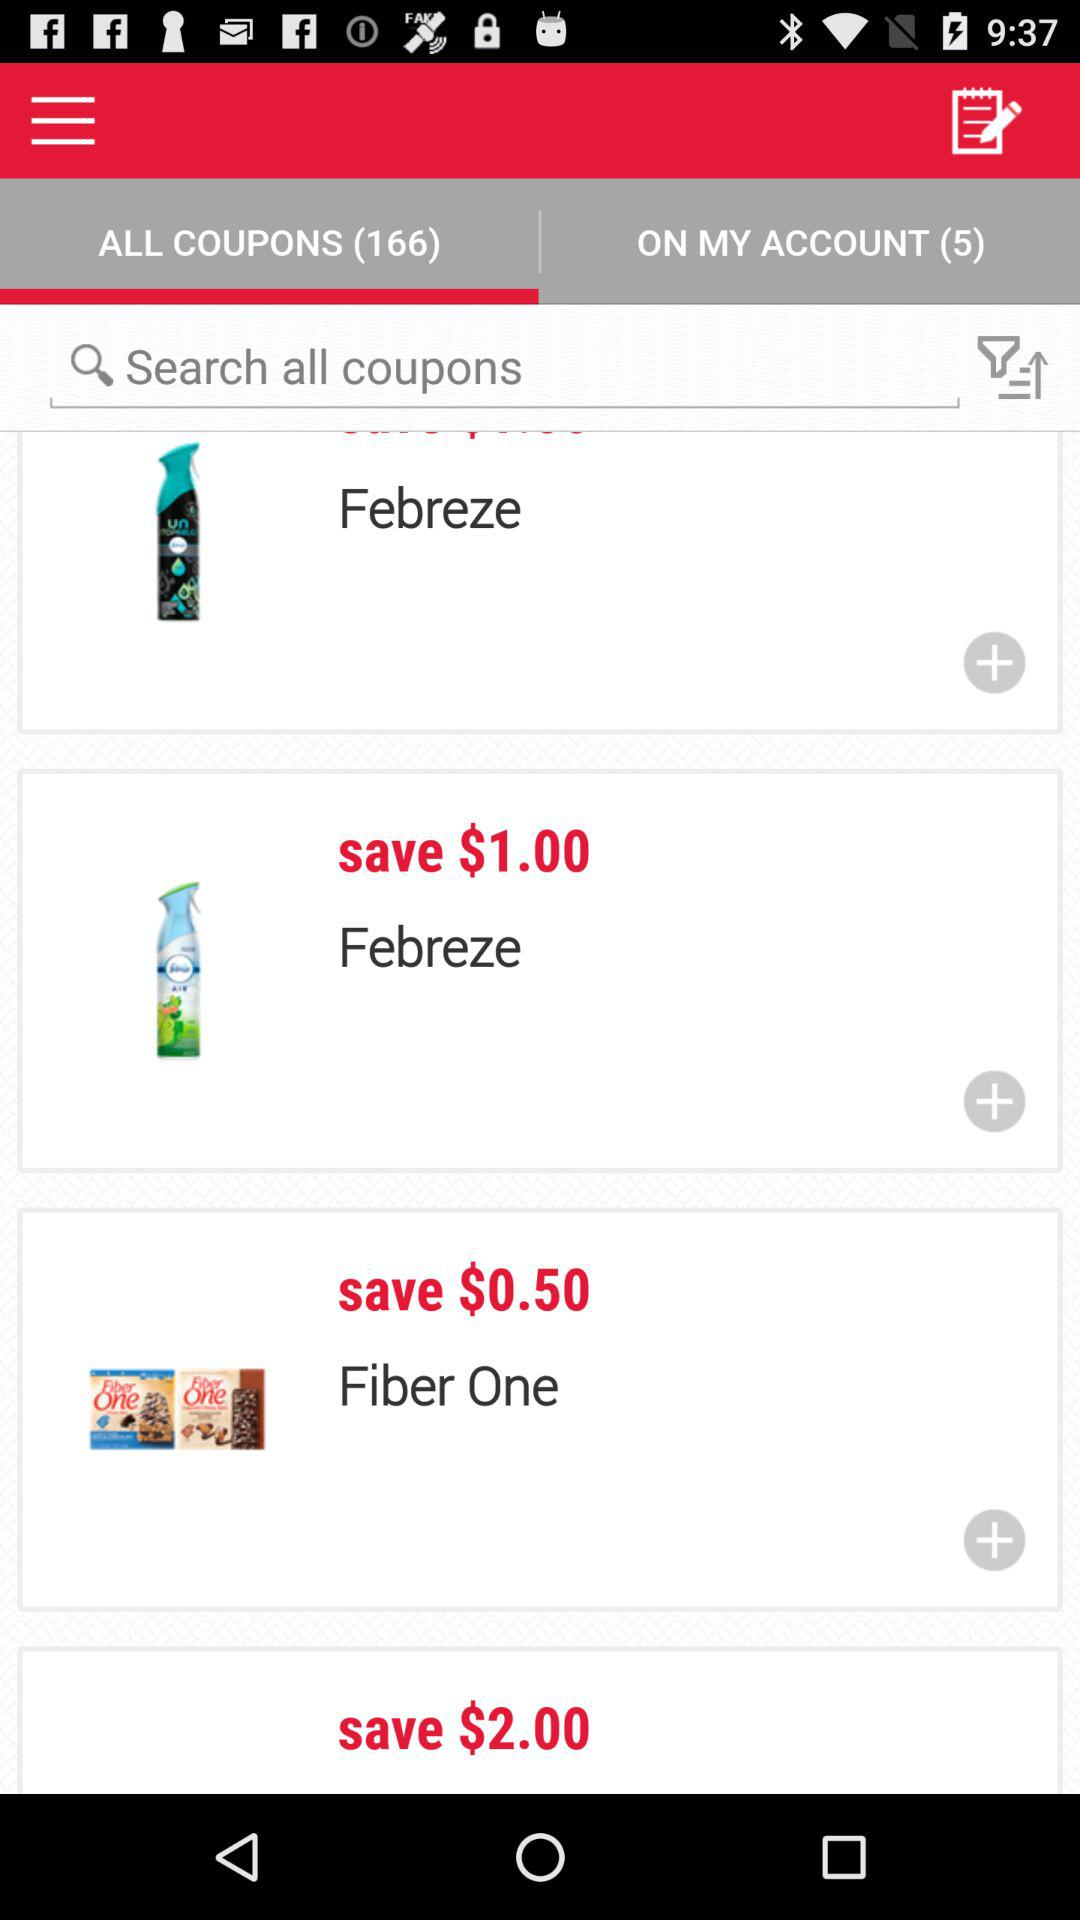What number is written after "ON MY ACCOUNT"? The number is 5. 